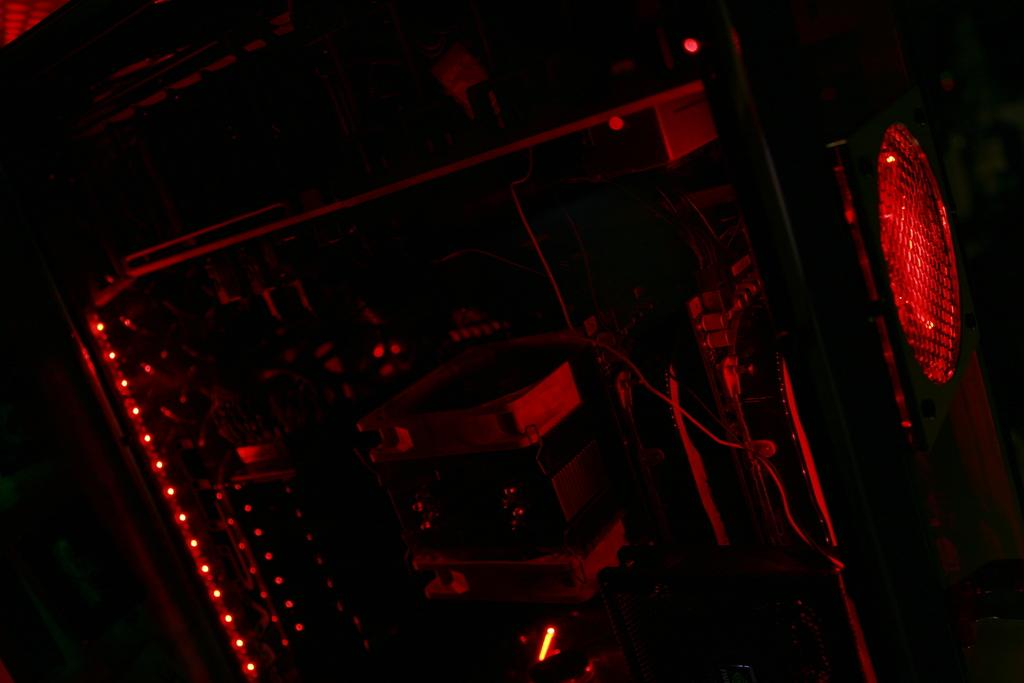What type of electronic device is in the image? There is an electronic gadget in the image, but the specific type is not mentioned. What is connected to the electronic gadget? There is a cable in the image, which may be connected to the electronic gadget. What can be seen illuminated in the image? There is a light in the image. How would you describe the overall lighting in the image? The background of the image is dark. How many jellyfish are swimming in the background of the image? There are no jellyfish present in the image; the background is dark, and no aquatic life is mentioned. What type of stretch exercise is the daughter performing in the image? There is no daughter or any person performing any exercise in the image; it features an electronic gadget, a cable, and a light. 